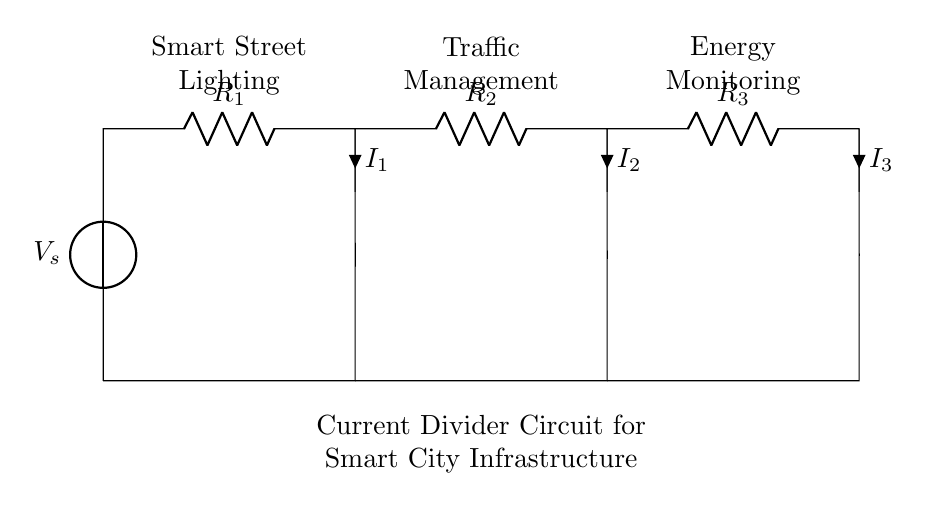What is the source voltage in this circuit? The voltage source, labeled as V_s, is the source of power for the circuit. The value for V_s is not specified in the diagram, but it is a critical component providing the voltage.
Answer: V_s What type of circuit is represented here? This configuration is a current divider circuit, which is designed to split the input current into several smaller currents across multiple branches.
Answer: Current divider How many resistances are present in this circuit? The circuit contains three resistances R_1, R_2, and R_3. Each resistance is connected in parallel, which is characteristic of a current divider arrangement.
Answer: Three What is the relationship between total current and individual branch currents? In a current divider, the total current entering the junction is equal to the sum of the currents flowing through each branch. Mathematically, it can be expressed as I_total = I_1 + I_2 + I_3. This relationship helps in analyzing how currents are distributed based on the resistances.
Answer: I_total = I_1 + I_2 + I_3 Which component specifically monitors energy usage in this infrastructure? The component labeled as "Energy Monitoring" corresponds to the part of the smart infrastructure that tracks and manages energy usage efficiently, which can help reduce costs and improve sustainability.
Answer: Energy Monitoring 